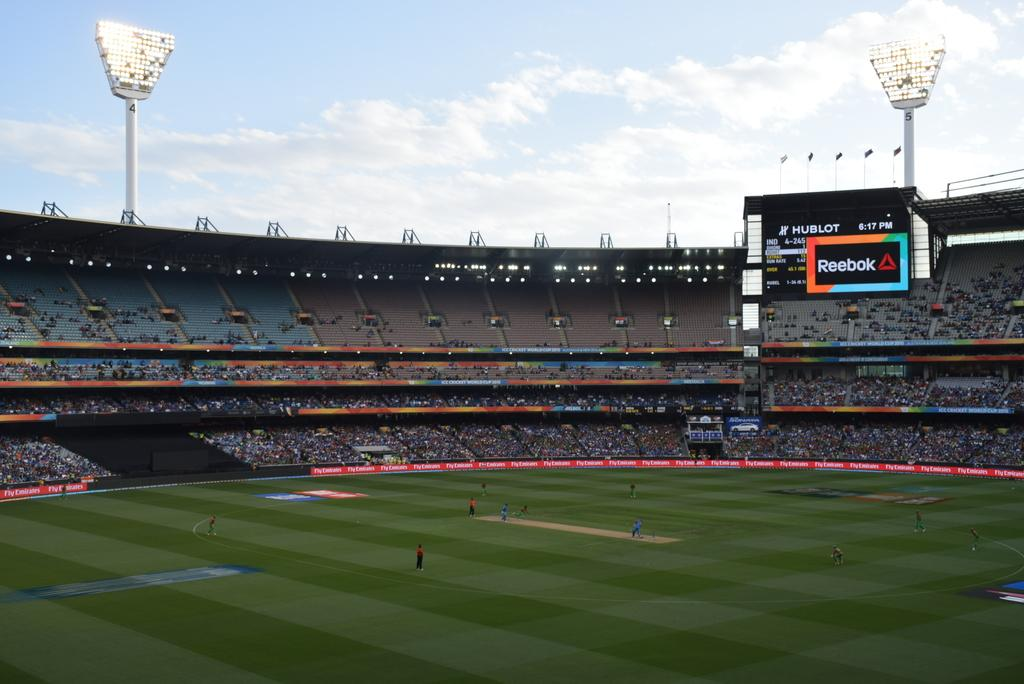<image>
Present a compact description of the photo's key features. A Reebok ad is on one of the big signs in this sports stadium. 